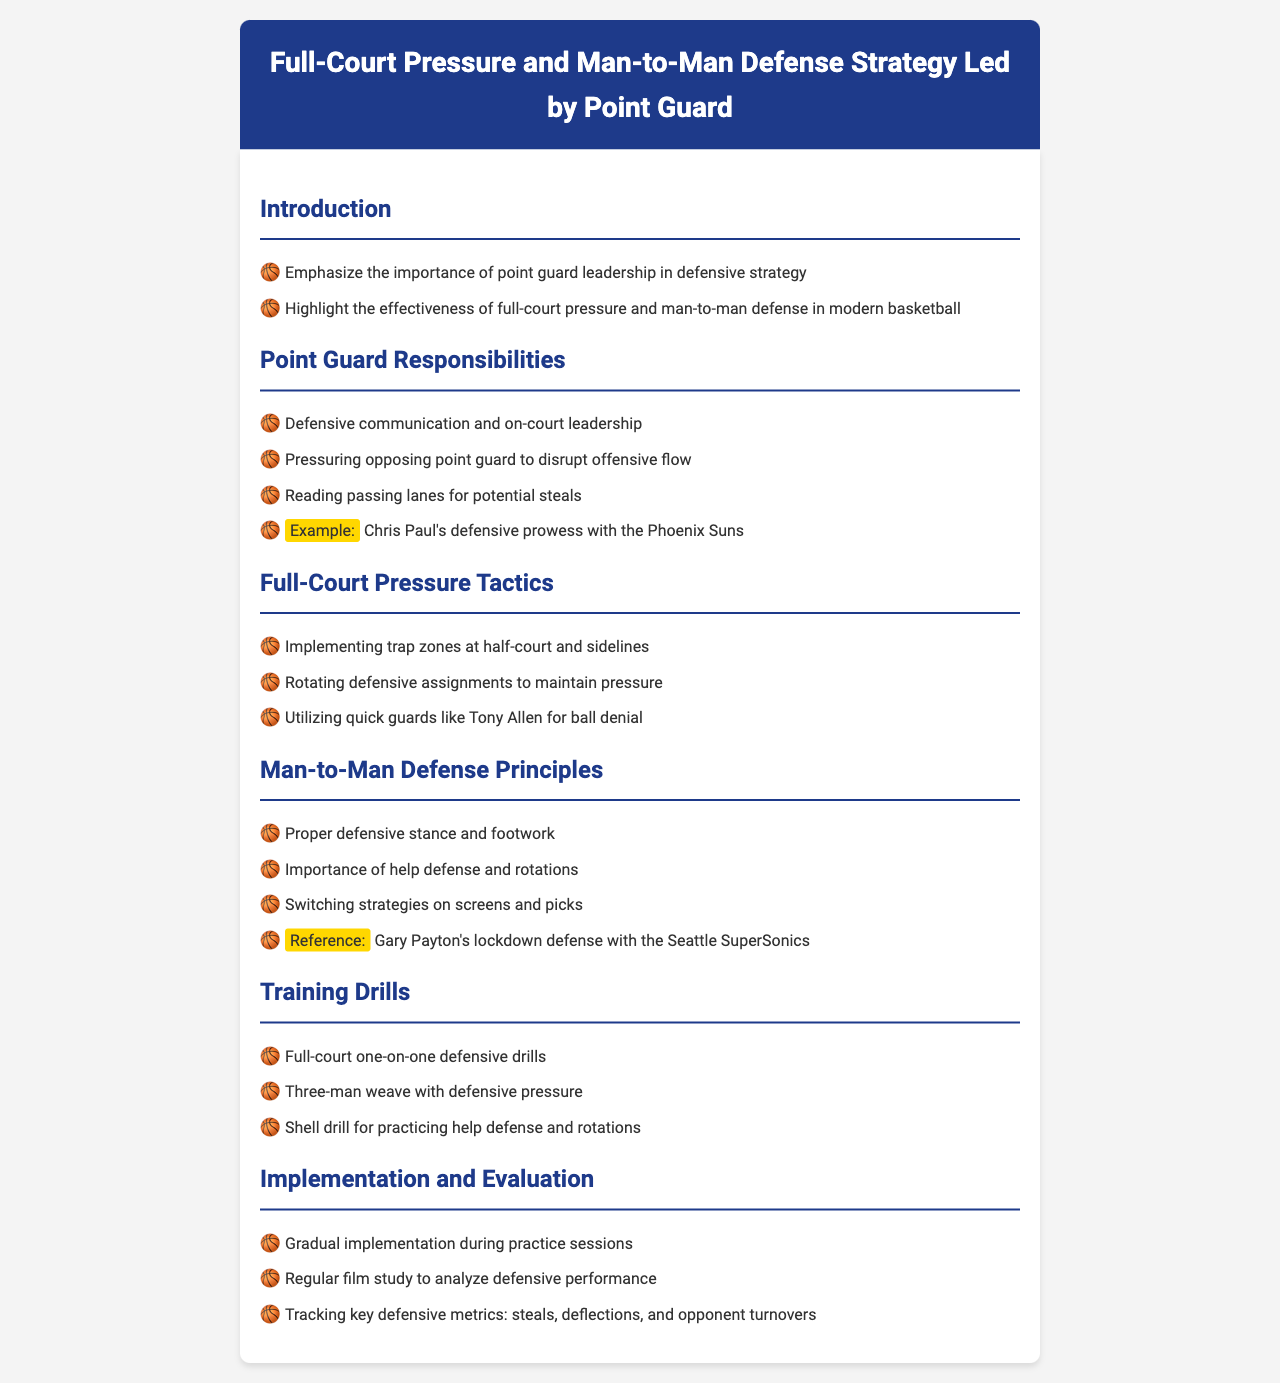What is the title of the document? The title is specified in the header section of the document, indicating the subject matter it covers.
Answer: Full-Court Pressure and Man-to-Man Defense Strategy Led by Point Guard Who is highlighted as an example of defensive prowess? The document provides an example in the context of point guard responsibilities, pointing out a specific player's contributions.
Answer: Chris Paul What defensive strategy is emphasized in the introduction? The introduction outlines the main focus of the strategy discussed in the document, particularly in a modern basketball context.
Answer: Full-court pressure and man-to-man defense What is one of the key responsibilities of the point guard? This can be found under the point guard responsibilities section and outlines a specific duty that is critical for defensive effectiveness.
Answer: Pressuring opposing point guard to disrupt offensive flow Which defensive drill is mentioned for practicing help defense? The training drills section lists specific activities aimed at improving various defensive skills.
Answer: Shell drill for practicing help defense and rotations What metric is used to evaluate defensive performance? Evaluation methods are described, including important statistics that help measure defensive success.
Answer: Steals, deflections, and opponent turnovers Which player's lockdown defense is referenced in the man-to-man defense principles? The document provides a reference to a notable player known for strong defensive skills in a specific context.
Answer: Gary Payton What type of drills are suggested for full-court pressure practice? The training drills section offers insights into the types of practice exercises that reinforce defensive tactics.
Answer: Full-court one-on-one defensive drills 